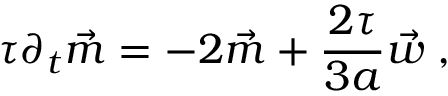Convert formula to latex. <formula><loc_0><loc_0><loc_500><loc_500>\tau \partial _ { t } \vec { m } = - 2 \vec { m } + \frac { 2 \tau } { 3 a } \vec { w } \, ,</formula> 